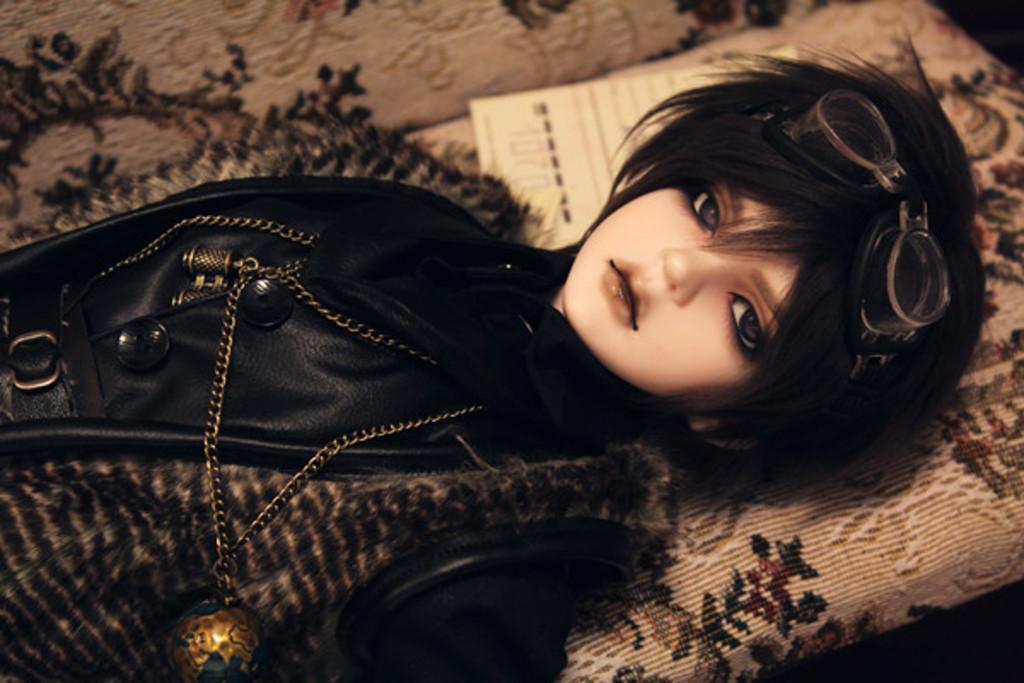Please provide a concise description of this image. In the image I can see a doll in black dress and spectacles who is laying on the sofa. 